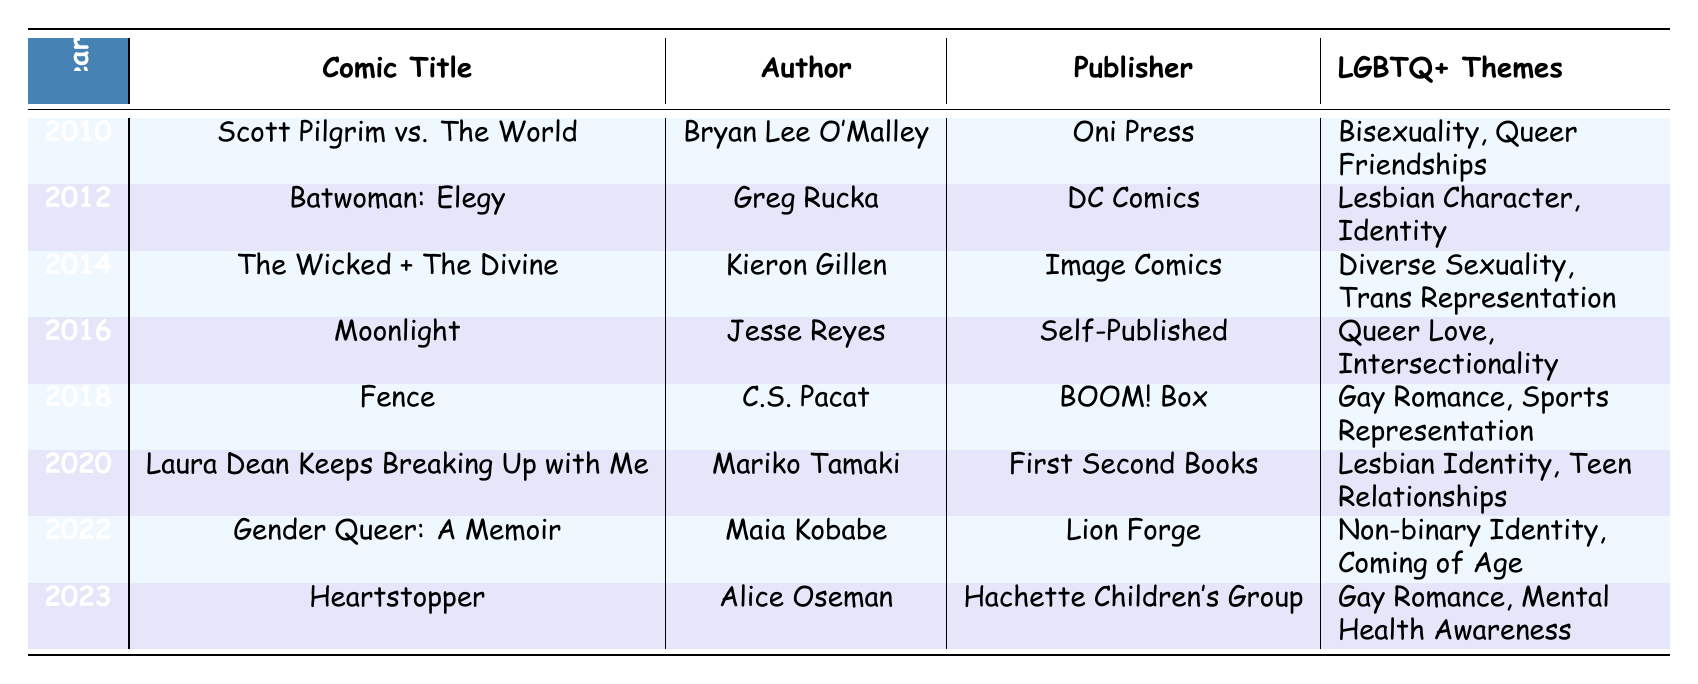What comic won an award in 2010? According to the table, the comic titled "Scott Pilgrim vs. The World" by Bryan Lee O'Malley won the Eisner Award for Best U.S. Edition of International Material in 2010.
Answer: Scott Pilgrim vs. The World Which comic represents non-binary identity? The table shows that "Gender Queer: A Memoir" by Maia Kobabe represents non-binary identity.
Answer: Gender Queer: A Memoir How many comics feature LGBTQ+ themes related to romance? By examining the table, the comics with LGBTQ+ themes related to romance are "Scott Pilgrim vs. The World," "Moonlight," "Fence," "Laura Dean Keeps Breaking Up with Me," and "Heartstopper," totaling five comics.
Answer: 5 Is "The Wicked + The Divine" an award-winning comic? Yes, "The Wicked + The Divine" won the British Comic Awards for Best Comic in 2014, confirming that it is an award-winning comic.
Answer: Yes What is the average number of years between awards for LGBTQ+ comics in this table? The years of entries are 2010, 2012, 2014, 2016, 2018, 2020, 2022, and 2023. The intervals are (2012-2010), (2014-2012), (2016-2014), (2018-2016), (2020-2018), (2022-2020), and (2023-2022), which give us 2, 2, 2, 2, 2, 2, and 1, respectively. The sum is 13 divided by 7 entries equals approximately 1.86 years, which rounds up to about 2 years as an average interval between awards.
Answer: 2 years 